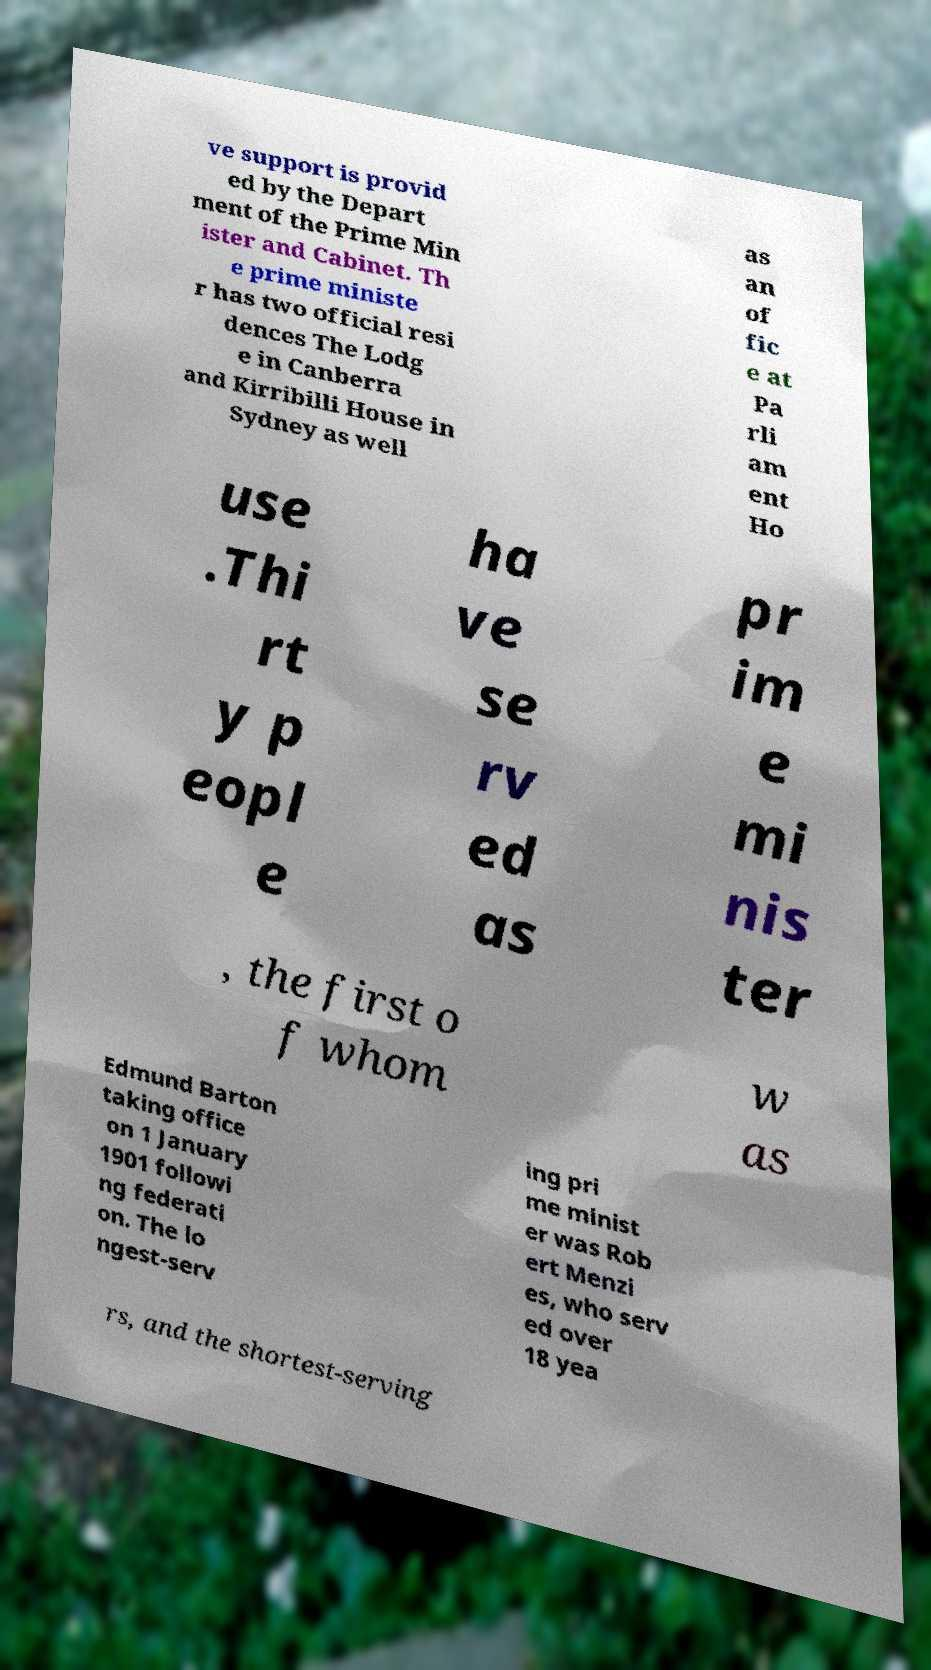I need the written content from this picture converted into text. Can you do that? ve support is provid ed by the Depart ment of the Prime Min ister and Cabinet. Th e prime ministe r has two official resi dences The Lodg e in Canberra and Kirribilli House in Sydney as well as an of fic e at Pa rli am ent Ho use .Thi rt y p eopl e ha ve se rv ed as pr im e mi nis ter , the first o f whom w as Edmund Barton taking office on 1 January 1901 followi ng federati on. The lo ngest-serv ing pri me minist er was Rob ert Menzi es, who serv ed over 18 yea rs, and the shortest-serving 